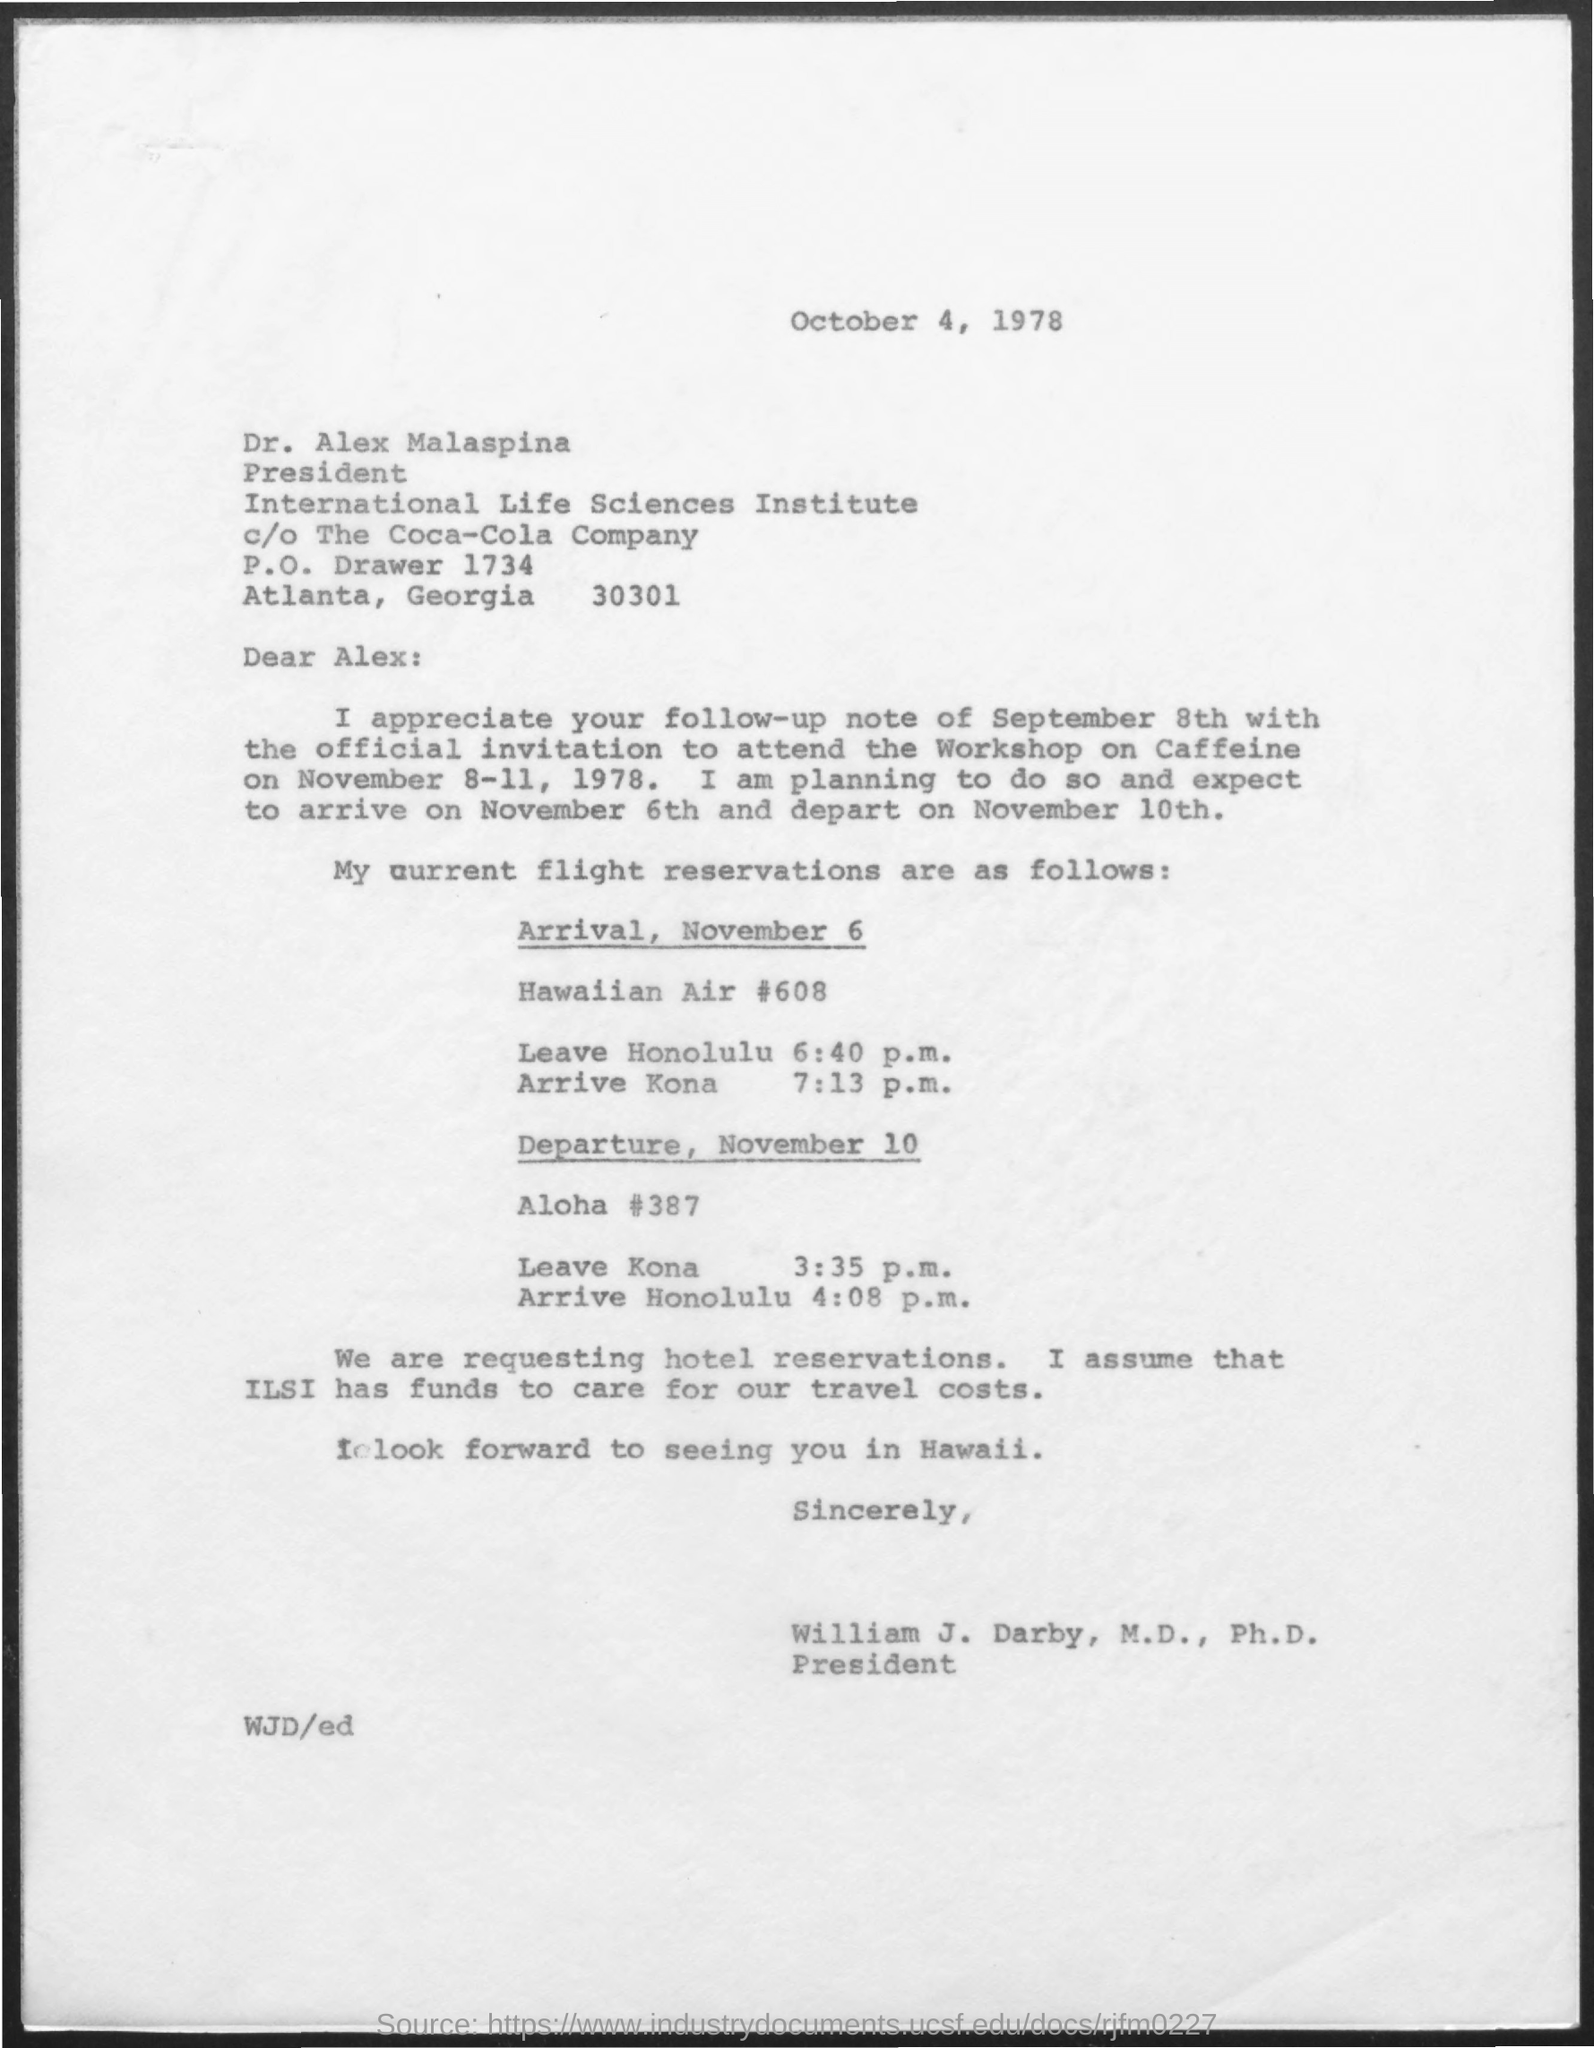Who is the president of international life science institute ?
Give a very brief answer. Dr. Alex Malaspina. 